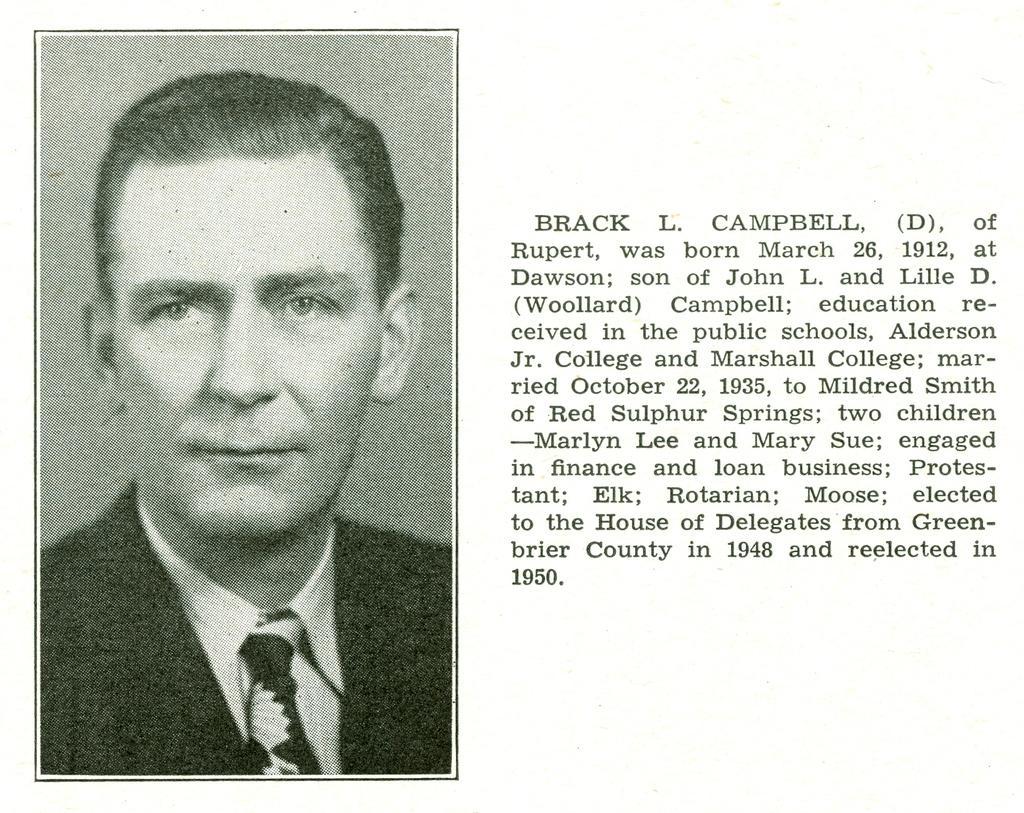Can you describe this image briefly? In this picture we can see a man´s photograph on the left side, we can see some text on the right side. 